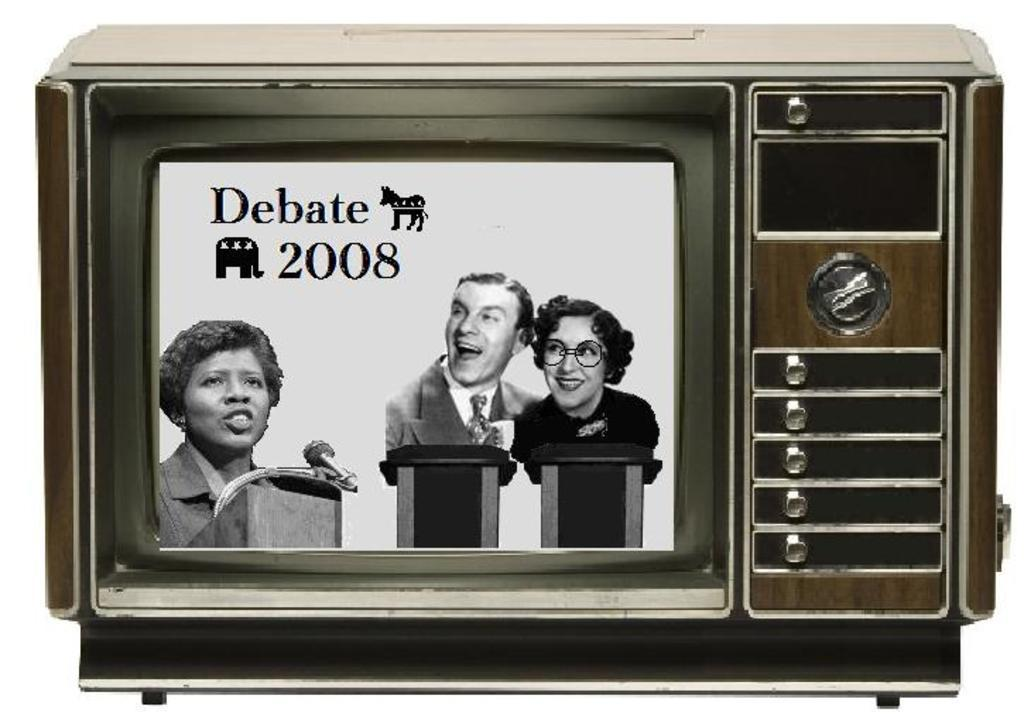What electronic device is present in the image? There is a television in the picture. What is displayed on the screen of the television? There are words, numbers, an image of three persons, podiums, a microphone, and animals on the screen of the television. Can you describe the content of the image on the screen of the television? The image on the screen of the television shows three persons, podiums, a microphone, and animals. How many jars are visible in the image on the screen of the television? There are no jars present in the image on the screen of the television. What type of gate can be seen in the image on the screen of the television? There is no gate present in the image on the screen of the television. 